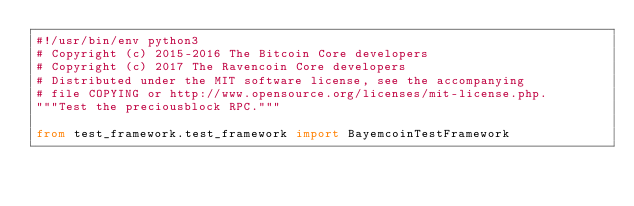<code> <loc_0><loc_0><loc_500><loc_500><_Python_>#!/usr/bin/env python3
# Copyright (c) 2015-2016 The Bitcoin Core developers
# Copyright (c) 2017 The Ravencoin Core developers
# Distributed under the MIT software license, see the accompanying
# file COPYING or http://www.opensource.org/licenses/mit-license.php.
"""Test the preciousblock RPC."""

from test_framework.test_framework import BayemcoinTestFramework</code> 